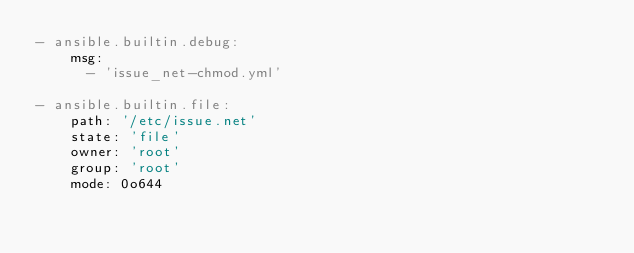<code> <loc_0><loc_0><loc_500><loc_500><_YAML_>- ansible.builtin.debug:
    msg:
      - 'issue_net-chmod.yml'

- ansible.builtin.file:
    path: '/etc/issue.net'
    state: 'file'
    owner: 'root'
    group: 'root'
    mode: 0o644
</code> 